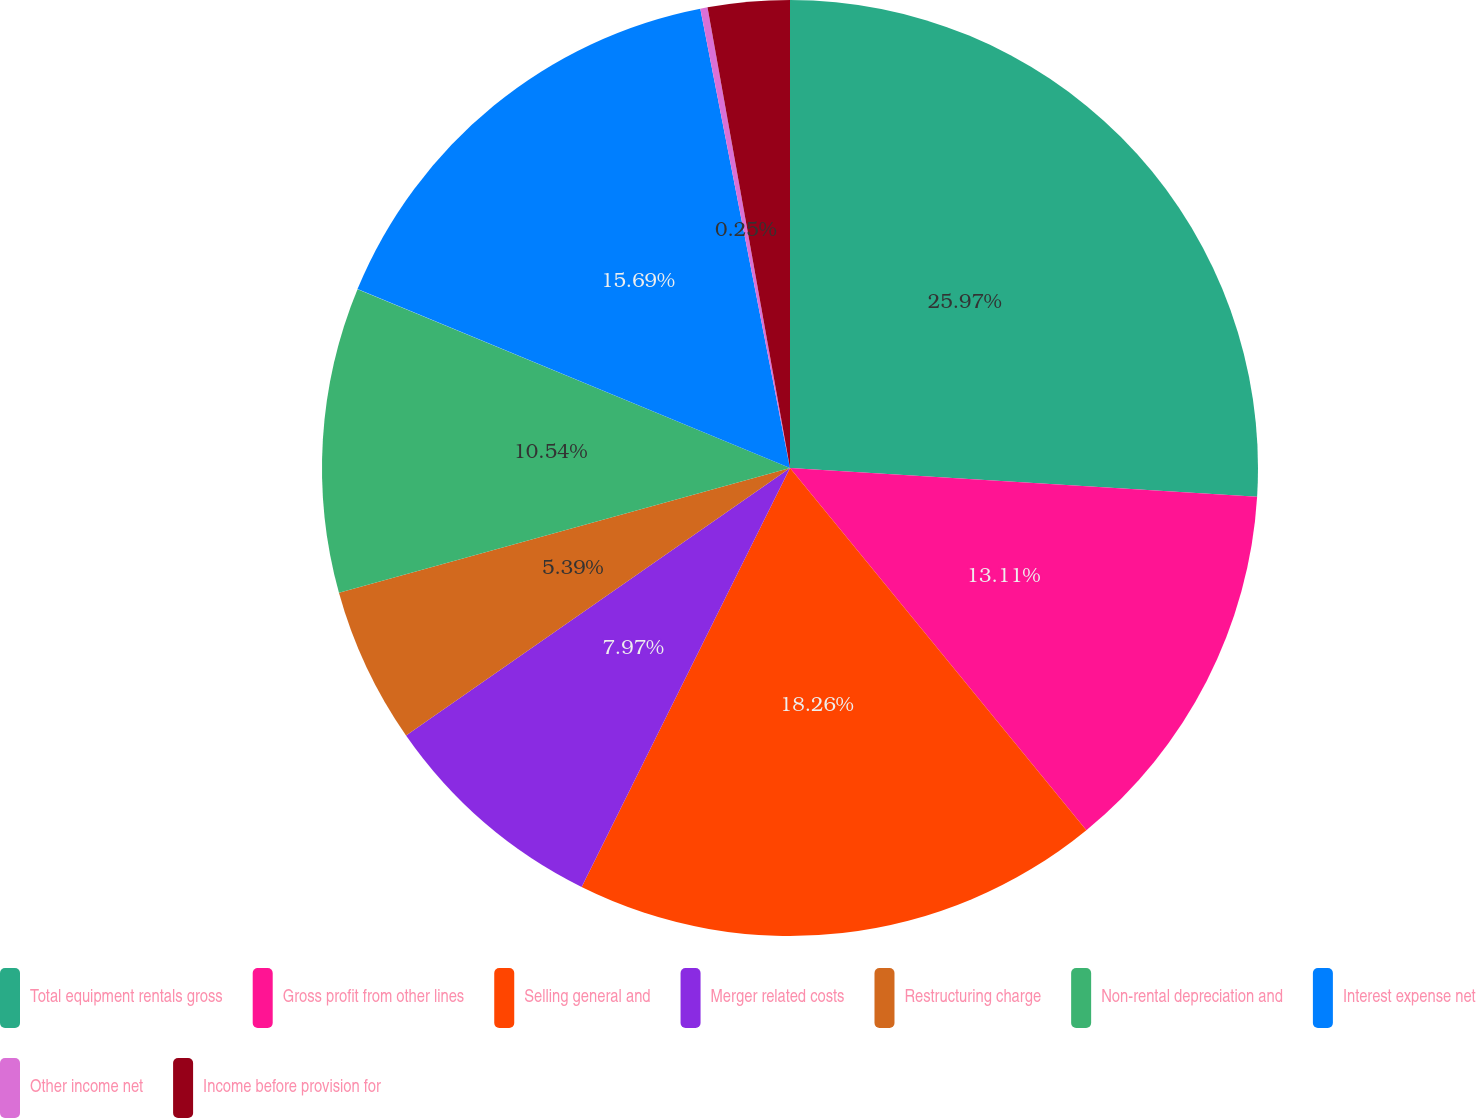Convert chart. <chart><loc_0><loc_0><loc_500><loc_500><pie_chart><fcel>Total equipment rentals gross<fcel>Gross profit from other lines<fcel>Selling general and<fcel>Merger related costs<fcel>Restructuring charge<fcel>Non-rental depreciation and<fcel>Interest expense net<fcel>Other income net<fcel>Income before provision for<nl><fcel>25.98%<fcel>13.11%<fcel>18.26%<fcel>7.97%<fcel>5.39%<fcel>10.54%<fcel>15.69%<fcel>0.25%<fcel>2.82%<nl></chart> 